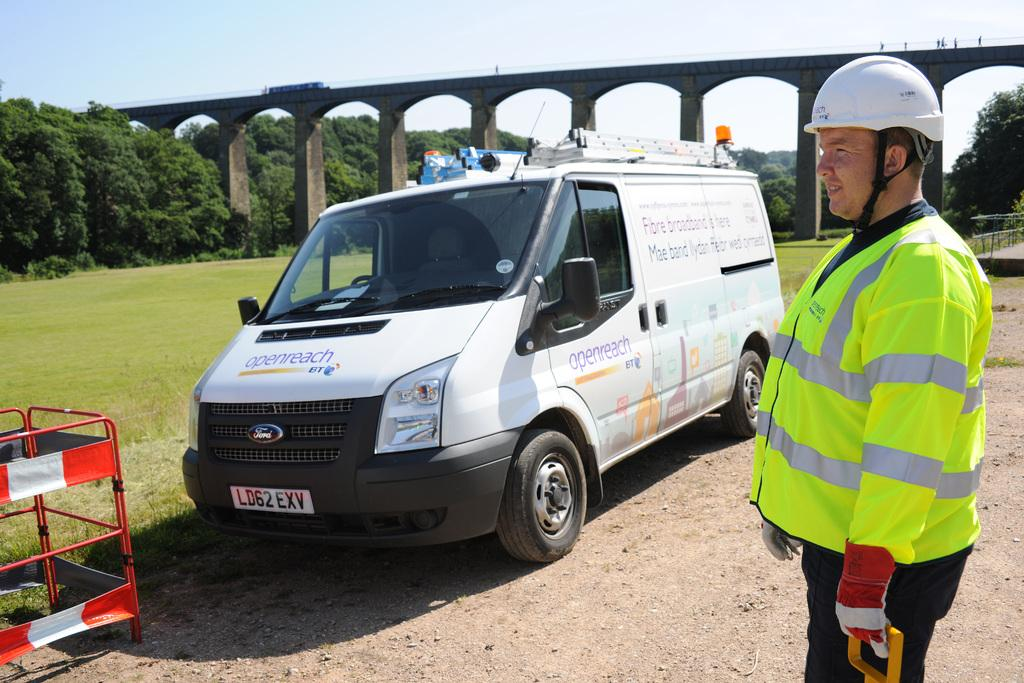Provide a one-sentence caption for the provided image. A maintenance worker in front of his van with the logo of the company Openreach. 